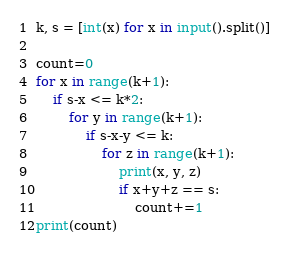<code> <loc_0><loc_0><loc_500><loc_500><_Python_>k, s = [int(x) for x in input().split()]

count=0
for x in range(k+1):
	if s-x <= k*2:
		for y in range(k+1):
			if s-x-y <= k:
				for z in range(k+1):
					print(x, y, z)
					if x+y+z == s:
						count+=1
print(count)</code> 